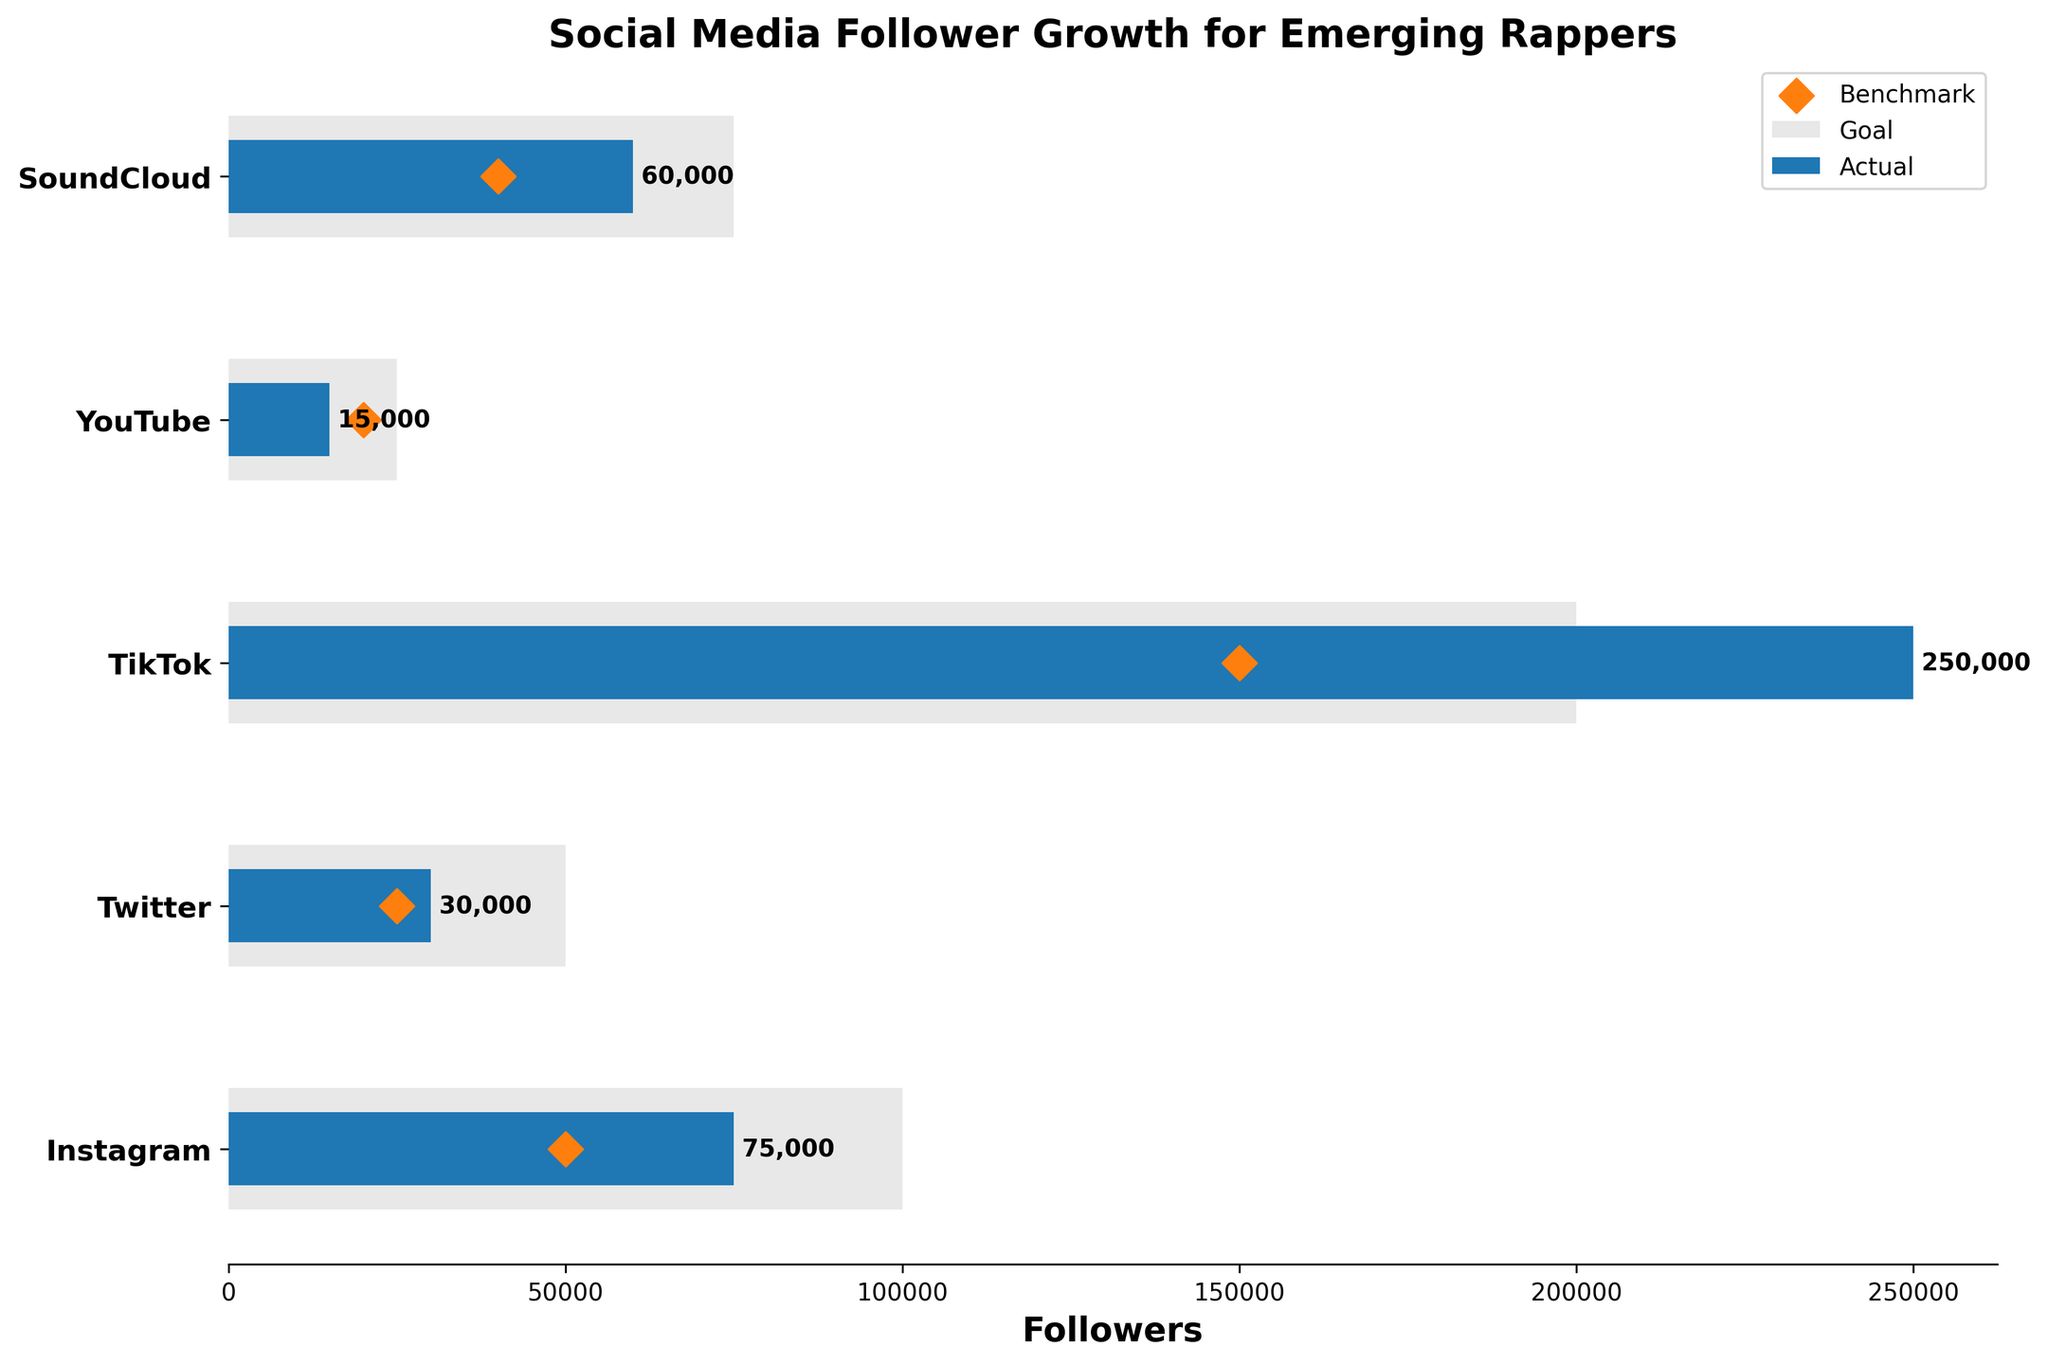What is the title of the chart? The title is situated at the top of the chart and is prominently displayed.
Answer: Social Media Follower Growth for Emerging Rappers How many platforms are displayed in the chart? Count the distinct platforms listed on the y-axis.
Answer: Five Which platform had the highest actual followers? Identify the platform with the longest bar for actual followers.
Answer: TikTok What is the benchmark value for YoungSteezzy on Instagram? Check the value marked with a diamond shape for the Instagram row.
Answer: 50,000 How much did BeatBoiPGH miss their goal on SoundCloud? Subtract the actual followers from the goal followers: 75,000 - 60,000 = 15,000.
Answer: 15,000 Which platform shows that the actual followers exceeded the goal? Identify the platform where the bar representing the actual followers is longer than the bar representing the goal.
Answer: TikTok Rank the platforms according to their benchmark values from highest to lowest. Arrange the benchmark values in descending order and list them by platform.
Answer: TikTok (150,000), Instagram (50,000), Twitter (25,000), SoundCloud (40,000), YouTube (20,000) What's the difference between the actual followers and the benchmark for RhymeTime on YouTube? Subtract the benchmark value from the actual follower value: 15,000 - 20,000 = -5,000.
Answer: -5,000 For which rapper did actual followers fall short of both the goal and the benchmark? Identify the row where the actual followers are less than both the goal and the benchmark values.
Answer: RhymeTime (YouTube) How many total followers did FlowMasta412 gain on TikTok compared to their benchmark and goal combined? Calculate the sum of the goal and the benchmark and compare it to the actual followers: 200,000 + 150,000 = 350,000; 250,000 compared to 350,000.
Answer: 250,000 